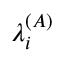Convert formula to latex. <formula><loc_0><loc_0><loc_500><loc_500>\lambda _ { i } ^ { ( A ) }</formula> 